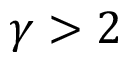Convert formula to latex. <formula><loc_0><loc_0><loc_500><loc_500>\gamma > 2</formula> 